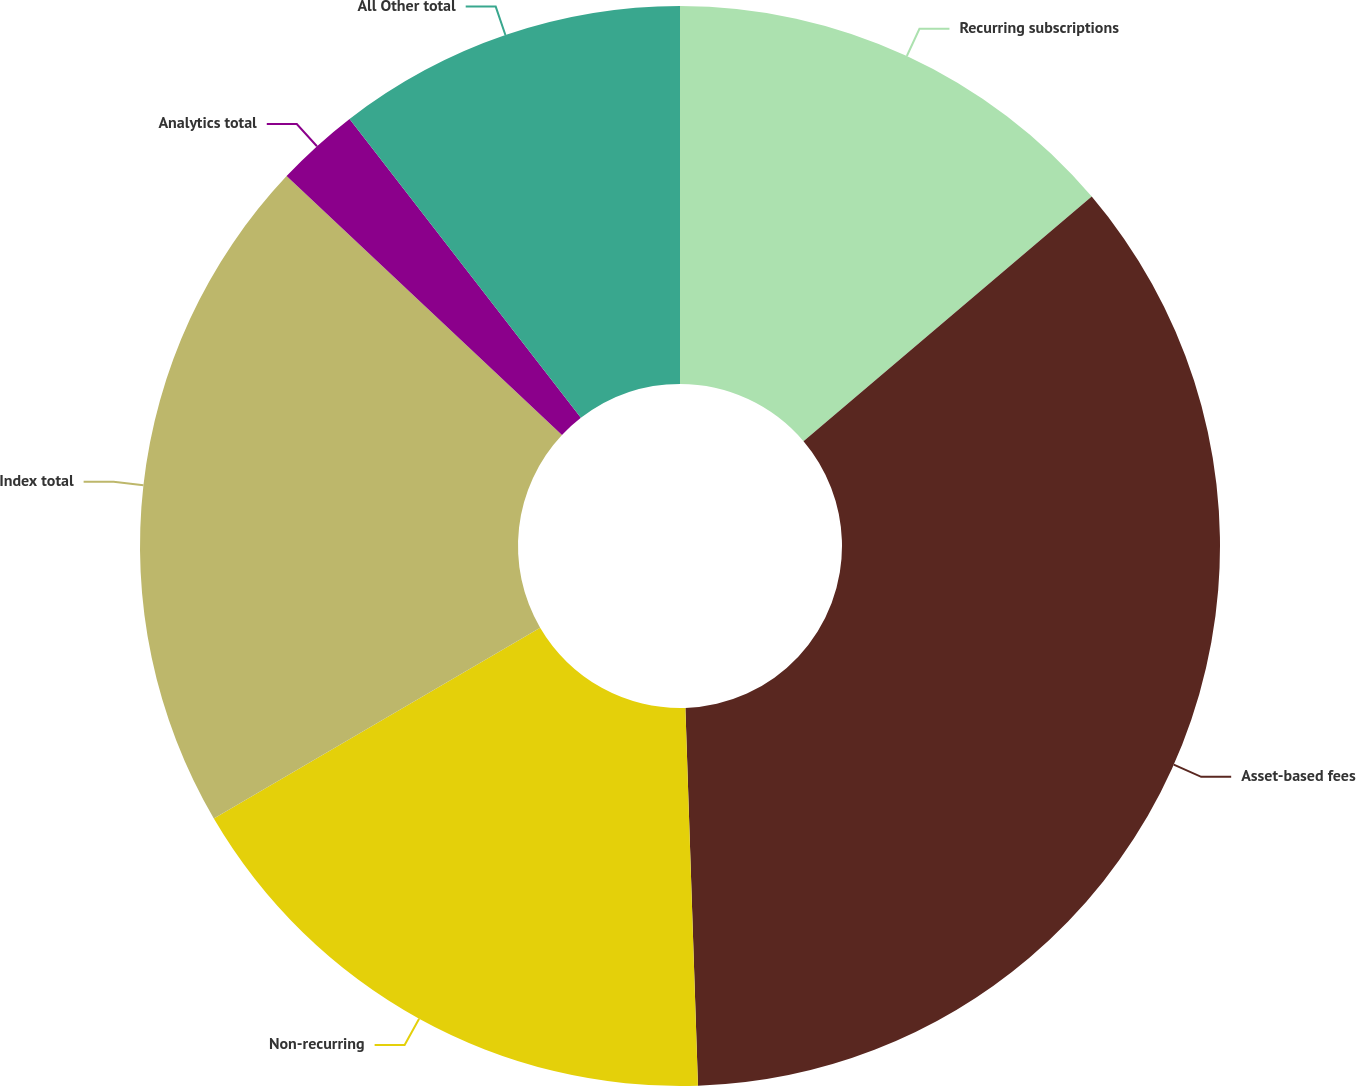Convert chart to OTSL. <chart><loc_0><loc_0><loc_500><loc_500><pie_chart><fcel>Recurring subscriptions<fcel>Asset-based fees<fcel>Non-recurring<fcel>Index total<fcel>Analytics total<fcel>All Other total<nl><fcel>13.8%<fcel>35.67%<fcel>17.11%<fcel>20.43%<fcel>2.51%<fcel>10.48%<nl></chart> 